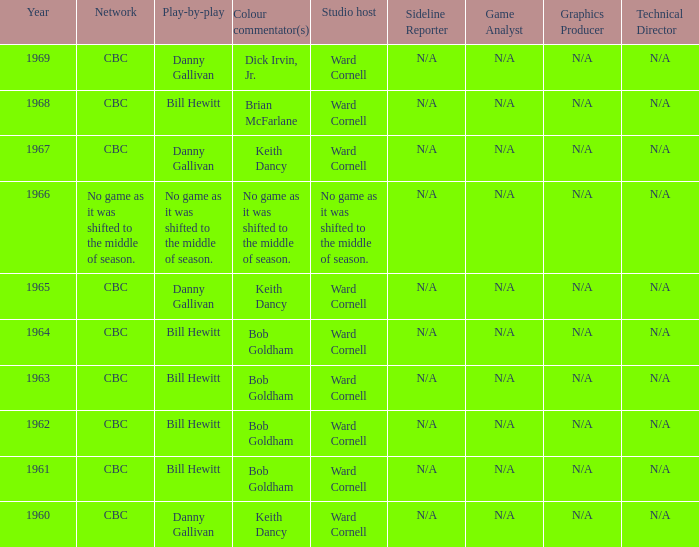Who did the play-by-play with studio host Ward Cornell and color commentator Bob Goldham? Bill Hewitt, Bill Hewitt, Bill Hewitt, Bill Hewitt. 